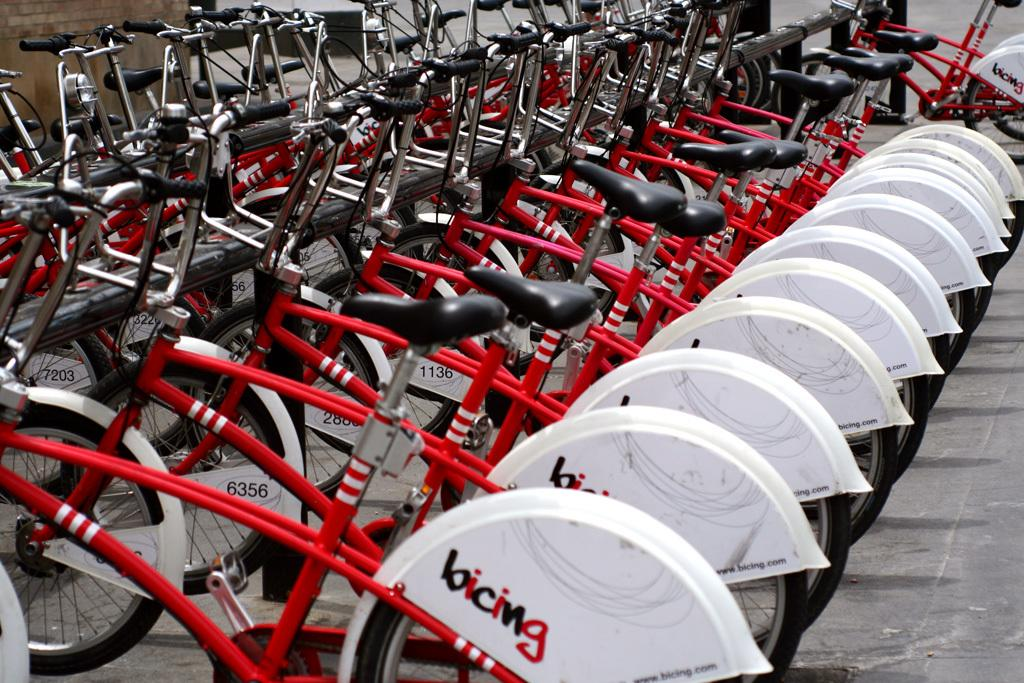What type of vehicles are in the picture? There are bicycles in the picture. What colors are the bicycles? The bicycles are red and white in color. Is there any text or writing on the bicycles? Yes, there is something written on the bicycles. What is the mass of the surprise element on the bicycles? There is no surprise element present on the bicycles in the image. 